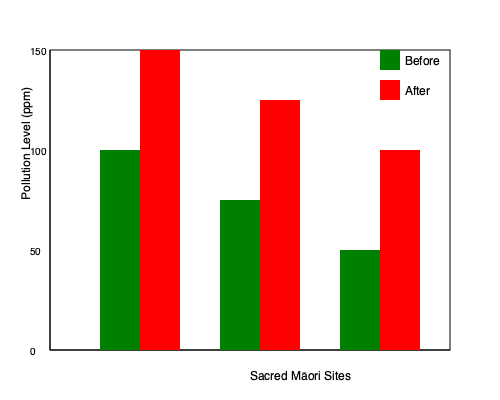Based on the bar graph comparing pollution levels in three sacred Māori sites before and after industrial activities, what is the average increase in pollution levels across all sites? To calculate the average increase in pollution levels:

1. Calculate the increase for each site:
   Site 1: 150 - 100 = 50 ppm
   Site 2: 125 - 75 = 50 ppm
   Site 3: 100 - 50 = 50 ppm

2. Sum up the increases:
   50 + 50 + 50 = 150 ppm

3. Divide the sum by the number of sites (3):
   150 ÷ 3 = 50 ppm

The average increase in pollution levels across all sites is 50 ppm.
Answer: 50 ppm 